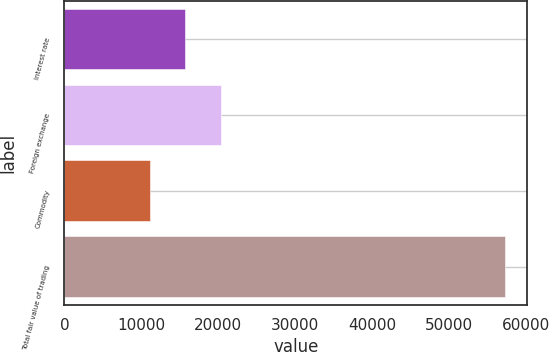<chart> <loc_0><loc_0><loc_500><loc_500><bar_chart><fcel>Interest rate<fcel>Foreign exchange<fcel>Commodity<fcel>Total fair value of trading<nl><fcel>15707<fcel>20330<fcel>11084<fcel>57314<nl></chart> 